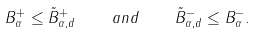Convert formula to latex. <formula><loc_0><loc_0><loc_500><loc_500>B _ { \alpha } ^ { + } \leq \tilde { B } _ { \alpha , d } ^ { + } \quad a n d \quad \tilde { B } _ { \alpha , d } ^ { - } \leq B _ { \alpha } ^ { - } .</formula> 